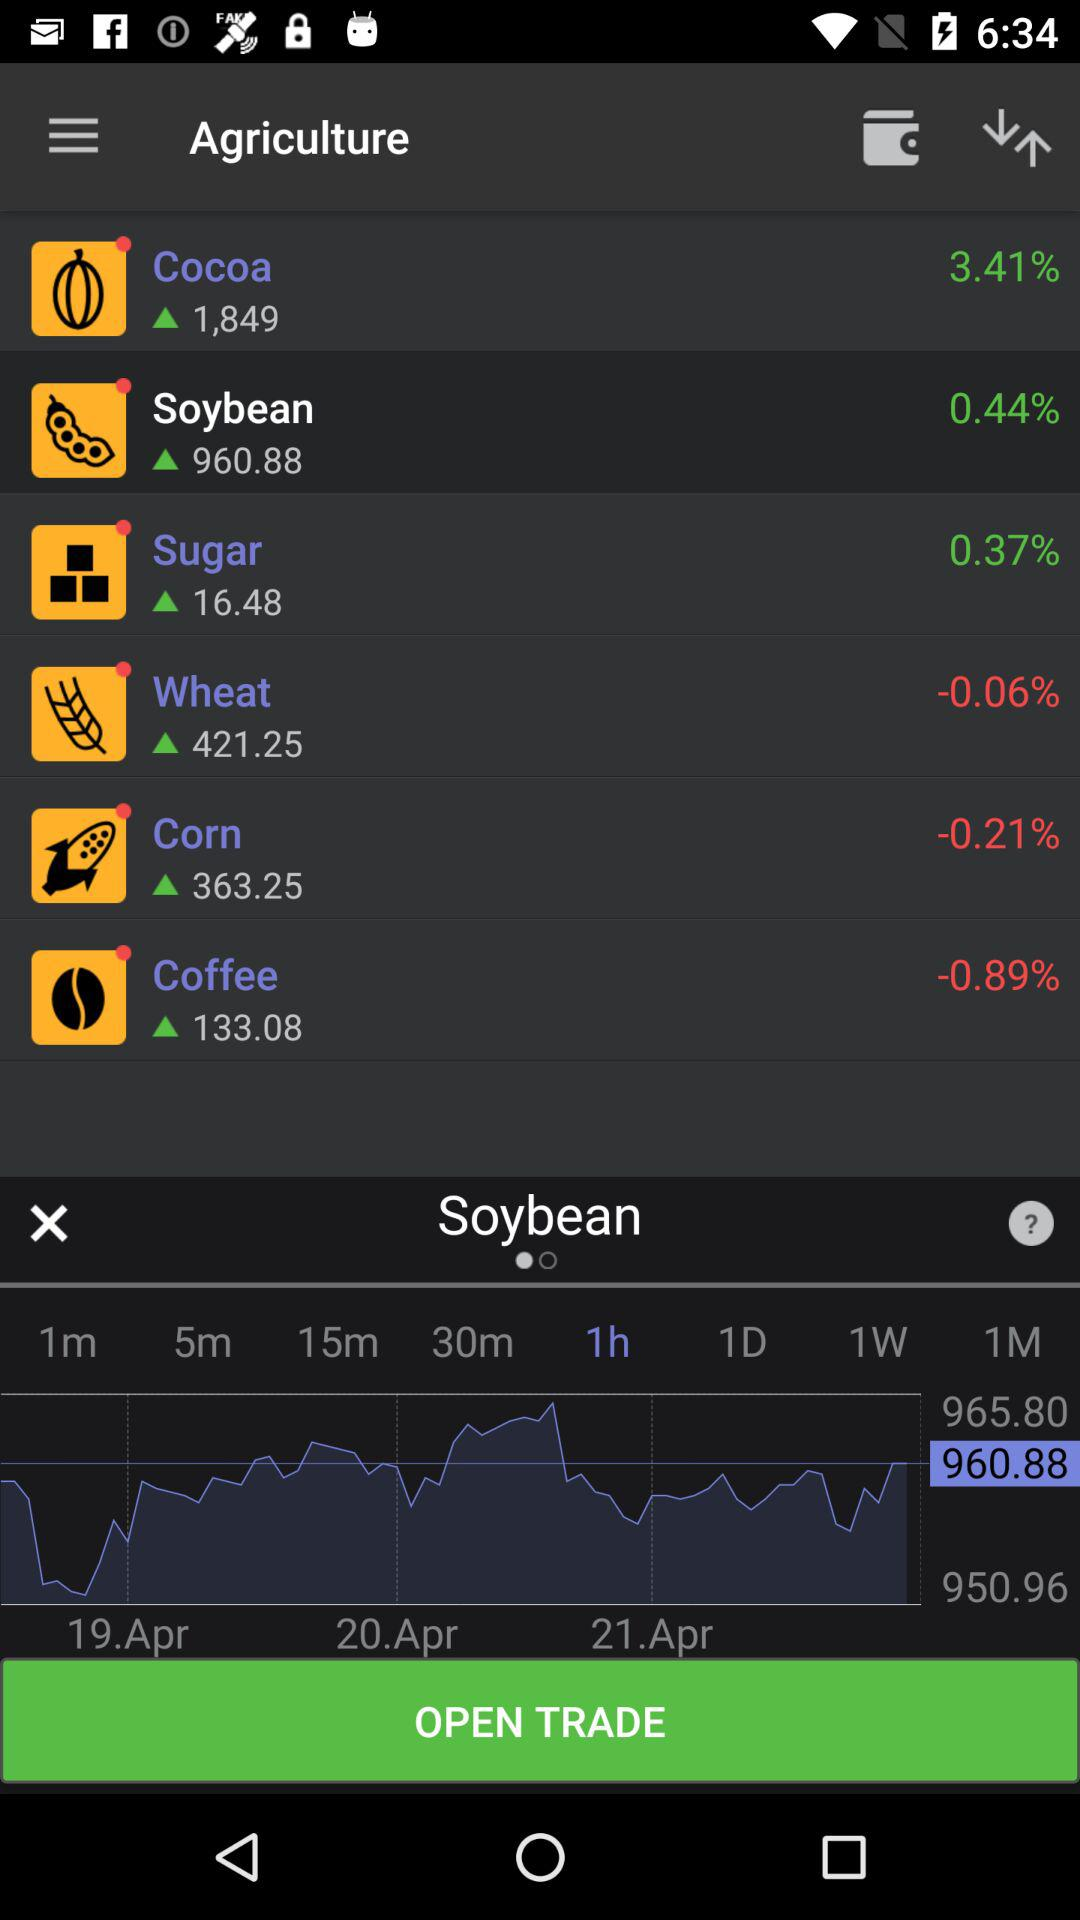Which product has a current price of 133.08? The product that has a current price of 133.08 is "Coffee". 